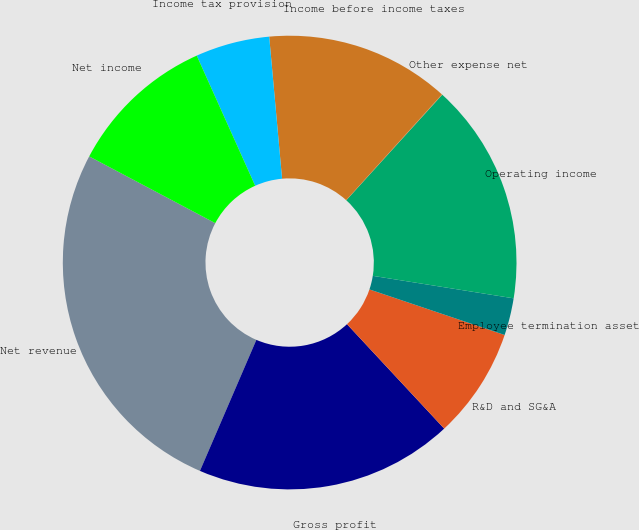<chart> <loc_0><loc_0><loc_500><loc_500><pie_chart><fcel>Net revenue<fcel>Gross profit<fcel>R&D and SG&A<fcel>Employee termination asset<fcel>Operating income<fcel>Other expense net<fcel>Income before income taxes<fcel>Income tax provision<fcel>Net income<nl><fcel>26.28%<fcel>18.4%<fcel>7.9%<fcel>2.65%<fcel>15.78%<fcel>0.03%<fcel>13.15%<fcel>5.28%<fcel>10.53%<nl></chart> 